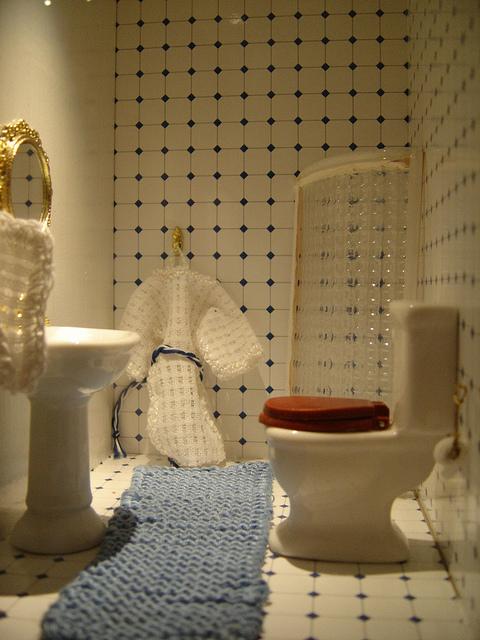Is there a shower?
Concise answer only. No. Does the room appear clean?
Give a very brief answer. Yes. What color is the rag?
Answer briefly. Blue. 